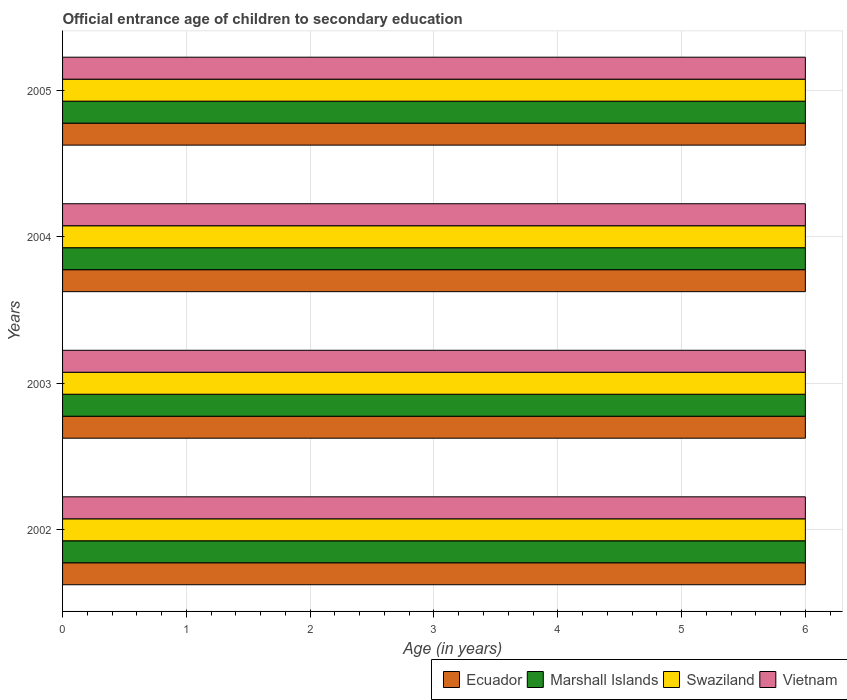How many different coloured bars are there?
Keep it short and to the point. 4. How many groups of bars are there?
Your response must be concise. 4. How many bars are there on the 2nd tick from the top?
Offer a terse response. 4. What is the label of the 3rd group of bars from the top?
Give a very brief answer. 2003. Across all years, what is the maximum secondary school starting age of children in Ecuador?
Offer a very short reply. 6. In which year was the secondary school starting age of children in Ecuador maximum?
Give a very brief answer. 2002. In which year was the secondary school starting age of children in Marshall Islands minimum?
Offer a very short reply. 2002. What is the total secondary school starting age of children in Ecuador in the graph?
Your answer should be very brief. 24. What is the difference between the secondary school starting age of children in Swaziland in 2003 and that in 2005?
Provide a succinct answer. 0. What is the ratio of the secondary school starting age of children in Ecuador in 2002 to that in 2004?
Offer a very short reply. 1. Is the difference between the secondary school starting age of children in Marshall Islands in 2003 and 2004 greater than the difference between the secondary school starting age of children in Ecuador in 2003 and 2004?
Keep it short and to the point. No. What is the difference between the highest and the second highest secondary school starting age of children in Vietnam?
Your answer should be compact. 0. What is the difference between the highest and the lowest secondary school starting age of children in Vietnam?
Make the answer very short. 0. Is the sum of the secondary school starting age of children in Marshall Islands in 2003 and 2004 greater than the maximum secondary school starting age of children in Ecuador across all years?
Offer a very short reply. Yes. Is it the case that in every year, the sum of the secondary school starting age of children in Marshall Islands and secondary school starting age of children in Ecuador is greater than the sum of secondary school starting age of children in Vietnam and secondary school starting age of children in Swaziland?
Your answer should be compact. No. What does the 4th bar from the top in 2003 represents?
Your answer should be compact. Ecuador. What does the 3rd bar from the bottom in 2005 represents?
Make the answer very short. Swaziland. Are the values on the major ticks of X-axis written in scientific E-notation?
Give a very brief answer. No. Does the graph contain any zero values?
Provide a succinct answer. No. Does the graph contain grids?
Keep it short and to the point. Yes. Where does the legend appear in the graph?
Keep it short and to the point. Bottom right. How are the legend labels stacked?
Give a very brief answer. Horizontal. What is the title of the graph?
Your answer should be compact. Official entrance age of children to secondary education. What is the label or title of the X-axis?
Ensure brevity in your answer.  Age (in years). What is the label or title of the Y-axis?
Give a very brief answer. Years. What is the Age (in years) of Ecuador in 2002?
Your answer should be compact. 6. What is the Age (in years) in Marshall Islands in 2002?
Make the answer very short. 6. What is the Age (in years) in Swaziland in 2003?
Provide a succinct answer. 6. What is the Age (in years) in Ecuador in 2004?
Keep it short and to the point. 6. What is the Age (in years) of Swaziland in 2004?
Your response must be concise. 6. What is the Age (in years) of Marshall Islands in 2005?
Provide a succinct answer. 6. What is the Age (in years) in Vietnam in 2005?
Your answer should be compact. 6. Across all years, what is the maximum Age (in years) of Swaziland?
Ensure brevity in your answer.  6. Across all years, what is the minimum Age (in years) of Swaziland?
Make the answer very short. 6. What is the total Age (in years) in Ecuador in the graph?
Make the answer very short. 24. What is the total Age (in years) of Swaziland in the graph?
Ensure brevity in your answer.  24. What is the difference between the Age (in years) of Marshall Islands in 2002 and that in 2003?
Provide a succinct answer. 0. What is the difference between the Age (in years) of Swaziland in 2002 and that in 2003?
Keep it short and to the point. 0. What is the difference between the Age (in years) of Vietnam in 2002 and that in 2003?
Your answer should be compact. 0. What is the difference between the Age (in years) of Marshall Islands in 2002 and that in 2004?
Make the answer very short. 0. What is the difference between the Age (in years) in Vietnam in 2002 and that in 2004?
Provide a short and direct response. 0. What is the difference between the Age (in years) in Ecuador in 2002 and that in 2005?
Make the answer very short. 0. What is the difference between the Age (in years) in Marshall Islands in 2002 and that in 2005?
Provide a short and direct response. 0. What is the difference between the Age (in years) of Vietnam in 2002 and that in 2005?
Keep it short and to the point. 0. What is the difference between the Age (in years) of Ecuador in 2003 and that in 2004?
Your answer should be very brief. 0. What is the difference between the Age (in years) in Marshall Islands in 2003 and that in 2004?
Make the answer very short. 0. What is the difference between the Age (in years) in Vietnam in 2003 and that in 2004?
Give a very brief answer. 0. What is the difference between the Age (in years) in Ecuador in 2003 and that in 2005?
Offer a terse response. 0. What is the difference between the Age (in years) of Vietnam in 2003 and that in 2005?
Make the answer very short. 0. What is the difference between the Age (in years) of Ecuador in 2004 and that in 2005?
Your answer should be very brief. 0. What is the difference between the Age (in years) in Marshall Islands in 2004 and that in 2005?
Your answer should be very brief. 0. What is the difference between the Age (in years) of Vietnam in 2004 and that in 2005?
Provide a succinct answer. 0. What is the difference between the Age (in years) of Marshall Islands in 2002 and the Age (in years) of Vietnam in 2003?
Offer a terse response. 0. What is the difference between the Age (in years) in Swaziland in 2002 and the Age (in years) in Vietnam in 2003?
Provide a short and direct response. 0. What is the difference between the Age (in years) in Ecuador in 2002 and the Age (in years) in Swaziland in 2004?
Provide a succinct answer. 0. What is the difference between the Age (in years) in Marshall Islands in 2002 and the Age (in years) in Vietnam in 2004?
Your answer should be compact. 0. What is the difference between the Age (in years) in Ecuador in 2002 and the Age (in years) in Swaziland in 2005?
Offer a very short reply. 0. What is the difference between the Age (in years) of Ecuador in 2002 and the Age (in years) of Vietnam in 2005?
Provide a short and direct response. 0. What is the difference between the Age (in years) of Marshall Islands in 2003 and the Age (in years) of Swaziland in 2004?
Your response must be concise. 0. What is the difference between the Age (in years) of Ecuador in 2003 and the Age (in years) of Marshall Islands in 2005?
Offer a terse response. 0. What is the difference between the Age (in years) of Ecuador in 2003 and the Age (in years) of Swaziland in 2005?
Offer a terse response. 0. What is the difference between the Age (in years) of Ecuador in 2003 and the Age (in years) of Vietnam in 2005?
Provide a short and direct response. 0. What is the difference between the Age (in years) of Swaziland in 2003 and the Age (in years) of Vietnam in 2005?
Make the answer very short. 0. What is the difference between the Age (in years) of Ecuador in 2004 and the Age (in years) of Marshall Islands in 2005?
Offer a very short reply. 0. What is the difference between the Age (in years) in Ecuador in 2004 and the Age (in years) in Swaziland in 2005?
Offer a very short reply. 0. What is the difference between the Age (in years) in Marshall Islands in 2004 and the Age (in years) in Swaziland in 2005?
Your answer should be very brief. 0. What is the difference between the Age (in years) of Marshall Islands in 2004 and the Age (in years) of Vietnam in 2005?
Keep it short and to the point. 0. What is the average Age (in years) of Marshall Islands per year?
Your response must be concise. 6. In the year 2002, what is the difference between the Age (in years) in Ecuador and Age (in years) in Vietnam?
Provide a succinct answer. 0. In the year 2002, what is the difference between the Age (in years) of Marshall Islands and Age (in years) of Swaziland?
Keep it short and to the point. 0. In the year 2002, what is the difference between the Age (in years) in Swaziland and Age (in years) in Vietnam?
Your answer should be very brief. 0. In the year 2003, what is the difference between the Age (in years) of Ecuador and Age (in years) of Vietnam?
Keep it short and to the point. 0. In the year 2003, what is the difference between the Age (in years) in Swaziland and Age (in years) in Vietnam?
Keep it short and to the point. 0. In the year 2004, what is the difference between the Age (in years) in Ecuador and Age (in years) in Swaziland?
Offer a very short reply. 0. In the year 2004, what is the difference between the Age (in years) in Marshall Islands and Age (in years) in Swaziland?
Ensure brevity in your answer.  0. In the year 2004, what is the difference between the Age (in years) in Marshall Islands and Age (in years) in Vietnam?
Ensure brevity in your answer.  0. In the year 2004, what is the difference between the Age (in years) of Swaziland and Age (in years) of Vietnam?
Offer a terse response. 0. In the year 2005, what is the difference between the Age (in years) of Ecuador and Age (in years) of Vietnam?
Provide a succinct answer. 0. In the year 2005, what is the difference between the Age (in years) in Marshall Islands and Age (in years) in Swaziland?
Provide a short and direct response. 0. In the year 2005, what is the difference between the Age (in years) in Marshall Islands and Age (in years) in Vietnam?
Give a very brief answer. 0. In the year 2005, what is the difference between the Age (in years) of Swaziland and Age (in years) of Vietnam?
Your answer should be compact. 0. What is the ratio of the Age (in years) in Vietnam in 2002 to that in 2003?
Your answer should be very brief. 1. What is the ratio of the Age (in years) of Vietnam in 2002 to that in 2005?
Offer a very short reply. 1. What is the ratio of the Age (in years) in Vietnam in 2003 to that in 2004?
Your response must be concise. 1. What is the ratio of the Age (in years) in Ecuador in 2003 to that in 2005?
Your response must be concise. 1. What is the ratio of the Age (in years) of Swaziland in 2003 to that in 2005?
Your answer should be very brief. 1. What is the ratio of the Age (in years) in Swaziland in 2004 to that in 2005?
Your response must be concise. 1. What is the ratio of the Age (in years) of Vietnam in 2004 to that in 2005?
Give a very brief answer. 1. What is the difference between the highest and the second highest Age (in years) in Marshall Islands?
Offer a terse response. 0. What is the difference between the highest and the second highest Age (in years) in Vietnam?
Make the answer very short. 0. What is the difference between the highest and the lowest Age (in years) in Ecuador?
Provide a succinct answer. 0. What is the difference between the highest and the lowest Age (in years) in Vietnam?
Your response must be concise. 0. 